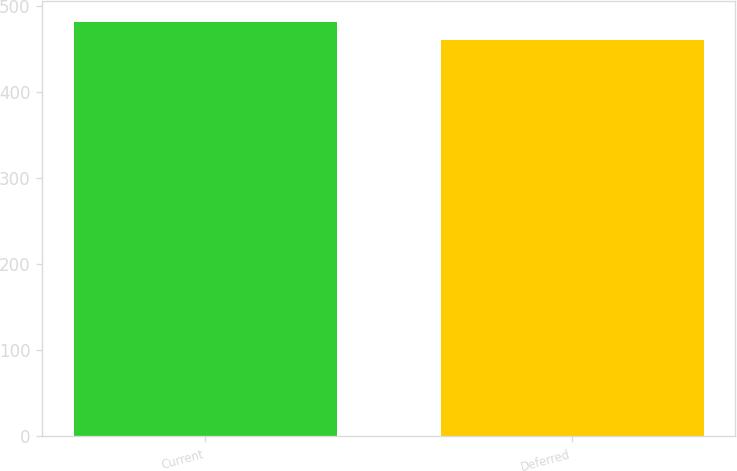<chart> <loc_0><loc_0><loc_500><loc_500><bar_chart><fcel>Current<fcel>Deferred<nl><fcel>481<fcel>460<nl></chart> 